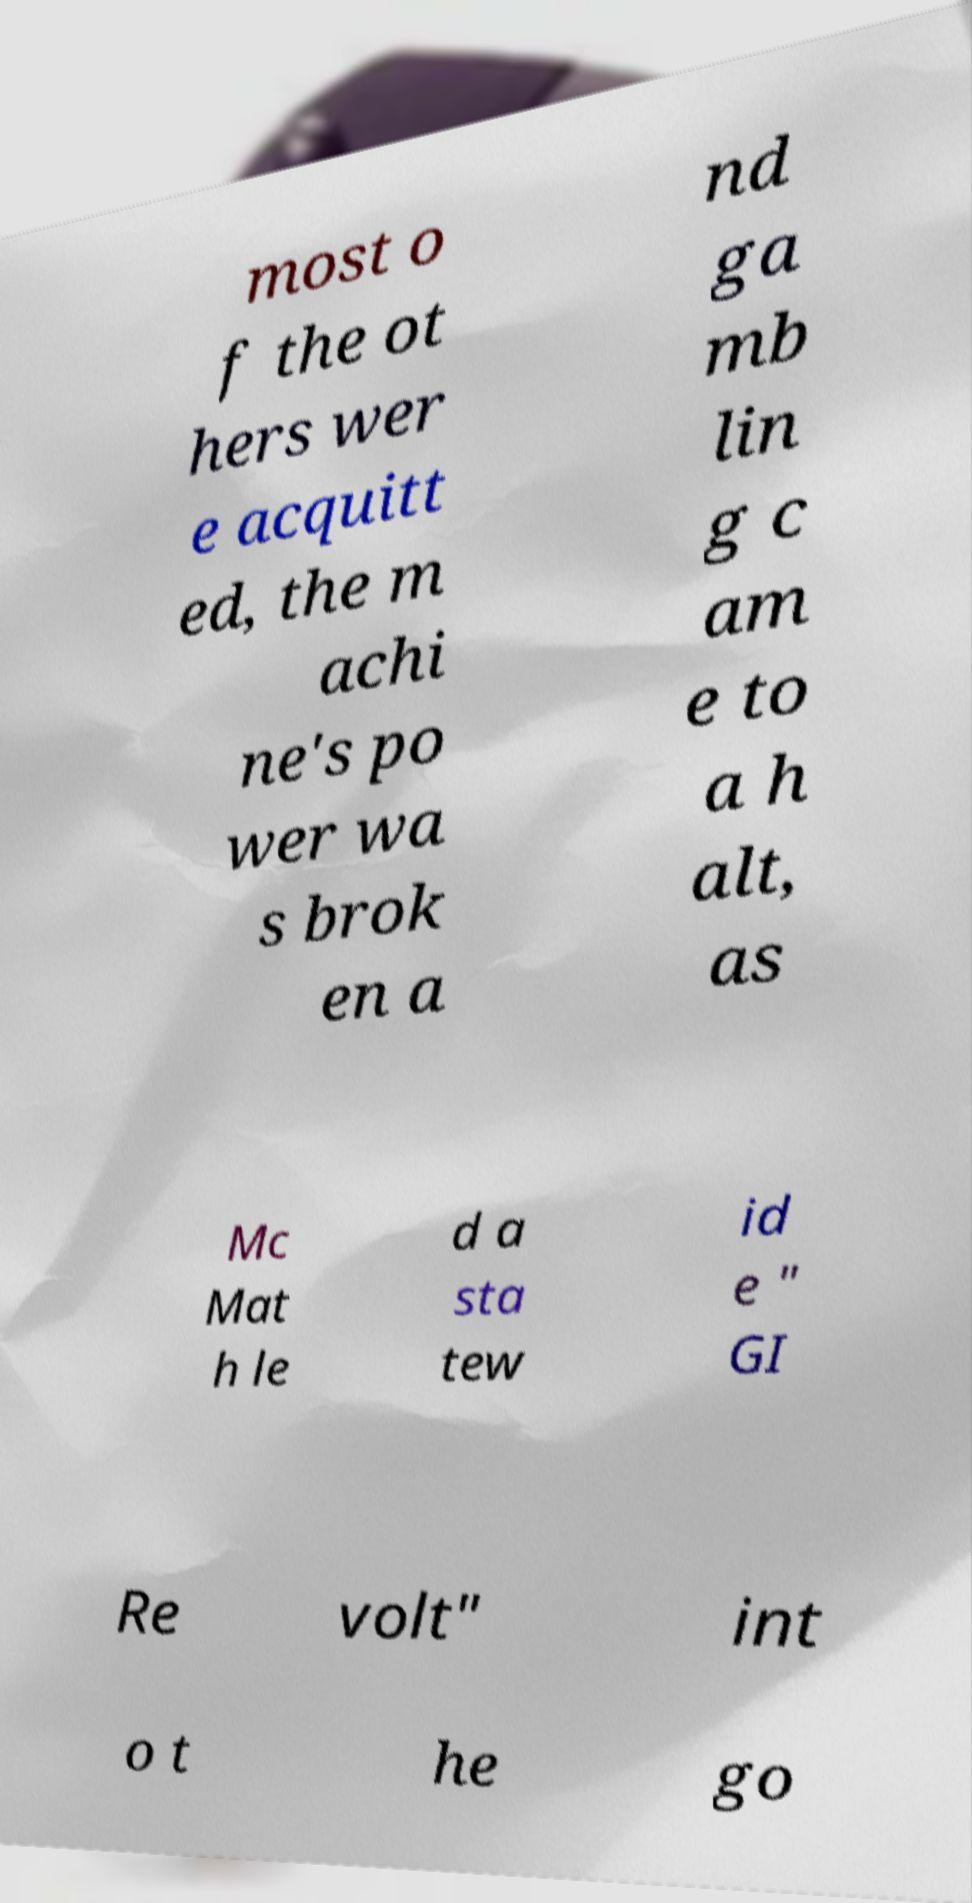For documentation purposes, I need the text within this image transcribed. Could you provide that? most o f the ot hers wer e acquitt ed, the m achi ne's po wer wa s brok en a nd ga mb lin g c am e to a h alt, as Mc Mat h le d a sta tew id e " GI Re volt" int o t he go 